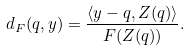Convert formula to latex. <formula><loc_0><loc_0><loc_500><loc_500>d _ { F } ( q , y ) = \frac { \langle y - q , Z ( q ) \rangle } { F ( Z ( q ) ) } .</formula> 